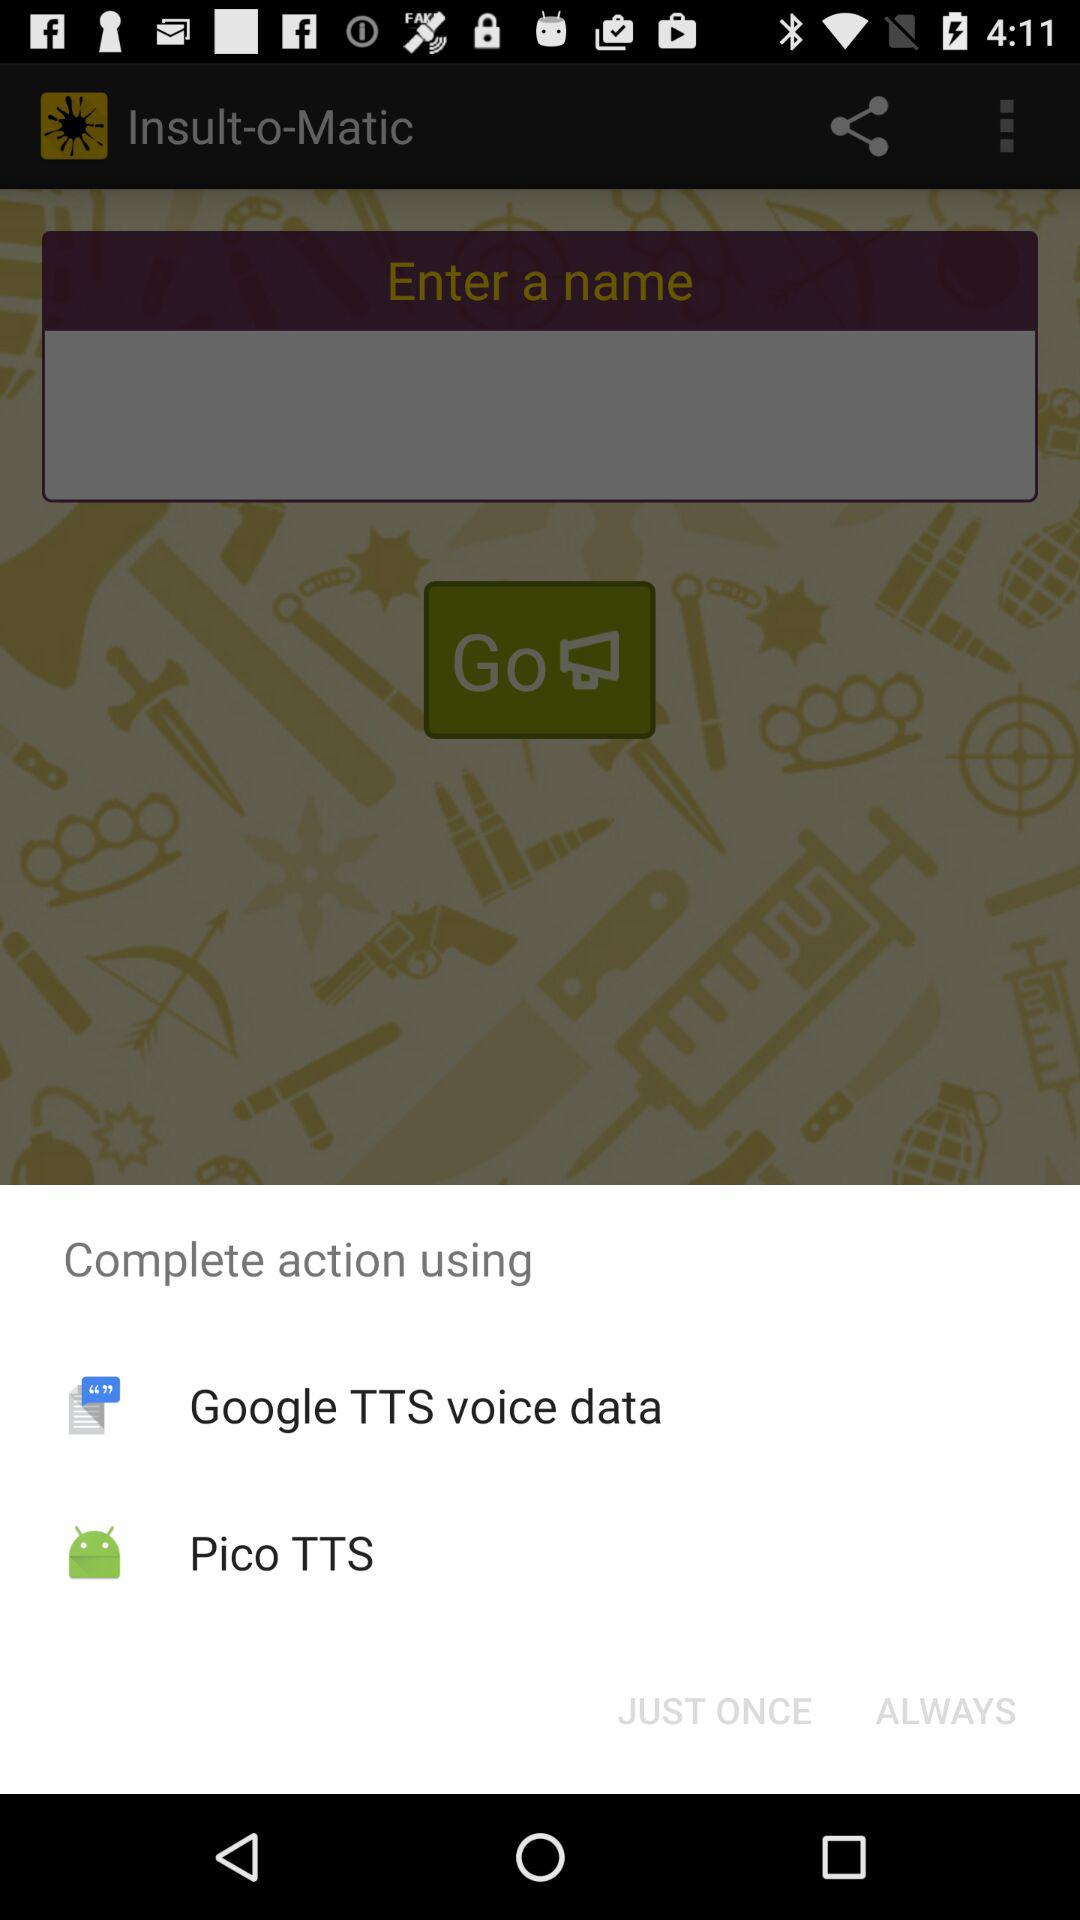What options are given for completing the action? The given options are "Google TTS voice data" and "Pico TTS". 